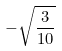Convert formula to latex. <formula><loc_0><loc_0><loc_500><loc_500>- \sqrt { \frac { 3 } { 1 0 } }</formula> 